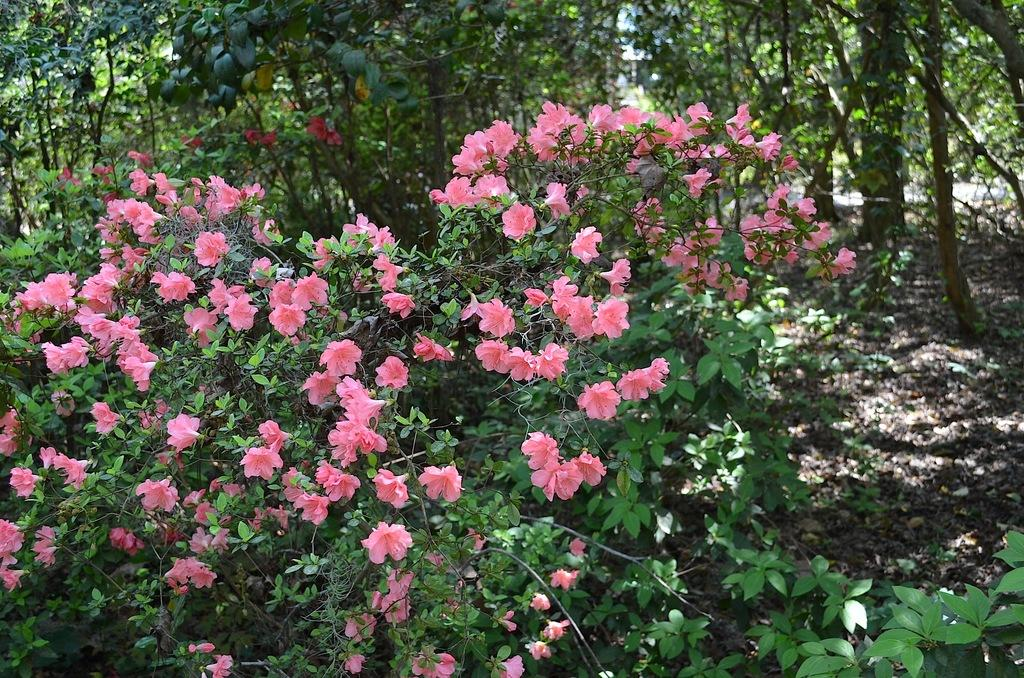What celestial bodies are depicted in the image? There are planets in the image. What type of flora can be seen in the image? There are pink flowers in the image. What can be seen in the background of the image? The background of the image contains trees. What type of architectural structure can be seen in the image? There is no architectural structure present in the image; it features planets, pink flowers, and trees. 